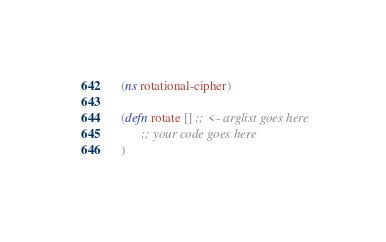Convert code to text. <code><loc_0><loc_0><loc_500><loc_500><_Clojure_>(ns rotational-cipher)

(defn rotate [] ;; <- arglist goes here
      ;; your code goes here
)
</code> 